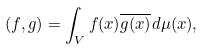<formula> <loc_0><loc_0><loc_500><loc_500>( f , g ) = \int _ { V } f ( x ) \overline { g ( x ) } d \mu ( x ) ,</formula> 